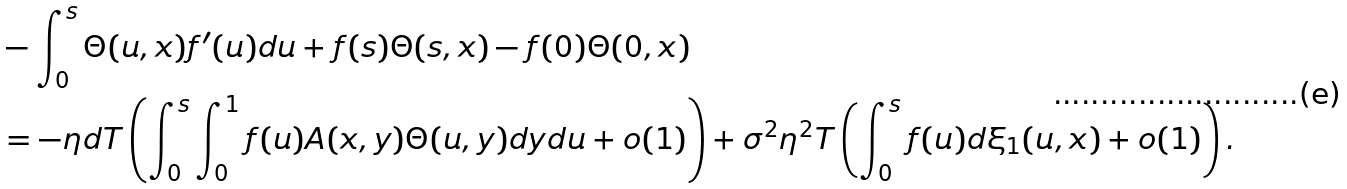Convert formula to latex. <formula><loc_0><loc_0><loc_500><loc_500>& - \int _ { 0 } ^ { s } \Theta ( u , x ) f ^ { \prime } ( u ) d u + f ( s ) { \Theta } ( s , x ) - f ( 0 ) { \Theta } ( 0 , x ) \\ & = - \eta d T \left ( \int _ { 0 } ^ { s } \int _ { 0 } ^ { 1 } f ( u ) A ( x , y ) \Theta ( u , y ) d y d u + o ( 1 ) \right ) + \sigma ^ { 2 } \eta ^ { 2 } T \left ( \int _ { 0 } ^ { s } f ( u ) d \xi _ { 1 } ( u , x ) + o ( 1 ) \right ) .</formula> 